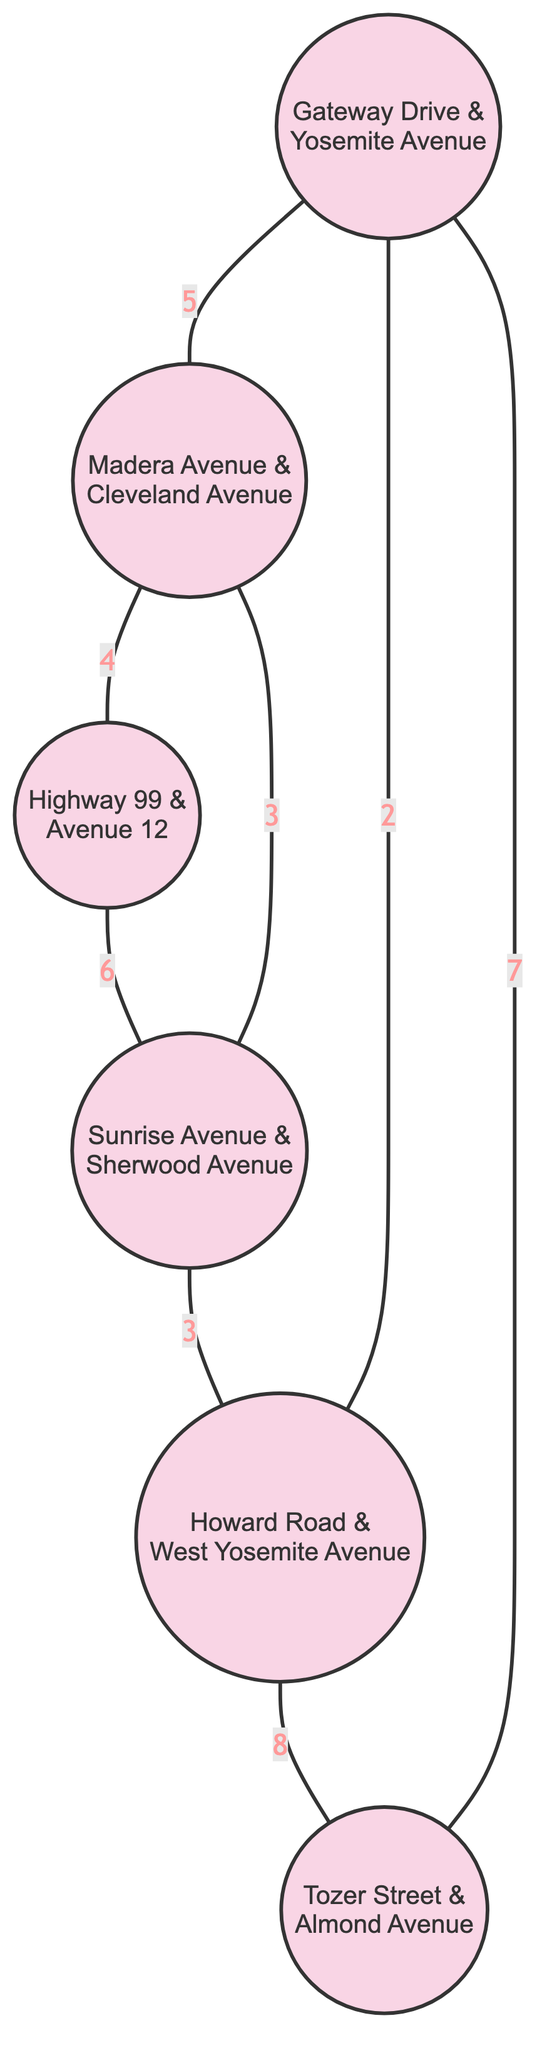What is the weight of the edge between Gateway Drive & Yosemite Avenue and Madera Avenue & Cleveland Avenue? The edge connects node 1 (Gateway Drive & Yosemite Avenue) and node 2 (Madera Avenue & Cleveland Avenue) and has a weight of 5, which indicates the severity of maintenance.
Answer: 5 How many total nodes are present in the diagram? The diagram lists 6 different intersections or road segments as nodes, which are Gateway Drive & Yosemite Avenue, Madera Avenue & Cleveland Avenue, Highway 99 & Avenue 12, Sunrise Avenue & Sherwood Avenue, Howard Road & West Yosemite Avenue, and Tozer Street & Almond Avenue.
Answer: 6 Which intersection has the highest maintenance weight connected to it? Tozer Street & Almond Avenue (node 6) is connected to Howard Road & West Yosemite Avenue (node 5) with the highest maintenance weight of 8, indicating it requires the most attention in terms of maintenance.
Answer: 8 Are there any edges connecting Madera Avenue & Cleveland Avenue to sunrise Avenue & Sherwood Avenue? There is an edge that connects node 2 (Madera Avenue & Cleveland Avenue) to node 4 (Sunrise Avenue & Sherwood Avenue) with a weight of 3, signifying a maintenance connection.
Answer: Yes How many edges connect to Gateway Drive & Yosemite Avenue? Gateway Drive & Yosemite Avenue (node 1) connects to three edges: one to Madera Avenue & Cleveland Avenue (weight 5), one to Howard Road & West Yosemite Avenue (weight 2), and one to Tozer Street & Almond Avenue (weight 7), totaling three connections.
Answer: 3 What is the total weight of the edges connected to Highway 99 & Avenue 12? Highway 99 & Avenue 12 (node 3) has two edges: one connecting to Madera Avenue & Cleveland Avenue (weight 4) and one to Sunrise Avenue & Sherwood Avenue (weight 6). Summing these weights gives a total of 4 + 6 = 10.
Answer: 10 Which two intersections are directly connected by the edge with the lowest weight? The edge with the lowest weight is between Gateway Drive & Yosemite Avenue (node 1) and Howard Road & West Yosemite Avenue (node 5) with a weight of 2, indicating it has the least maintenance severity relative to others.
Answer: Gateway Drive & Yosemite Avenue and Howard Road & West Yosemite Avenue What is the edge weight between Sunrise Avenue & Sherwood Avenue and Howard Road & West Yosemite Avenue? The edge connects node 4 (Sunrise Avenue & Sherwood Avenue) and node 5 (Howard Road & West Yosemite Avenue) with a weight of 3, indicating the level of maintenance required.
Answer: 3 